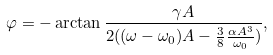<formula> <loc_0><loc_0><loc_500><loc_500>\varphi = - \arctan \frac { \gamma A } { 2 ( ( \omega - \omega _ { 0 } ) A - \frac { 3 } { 8 } \frac { \alpha A ^ { 3 } } { \omega _ { 0 } } ) } ,</formula> 